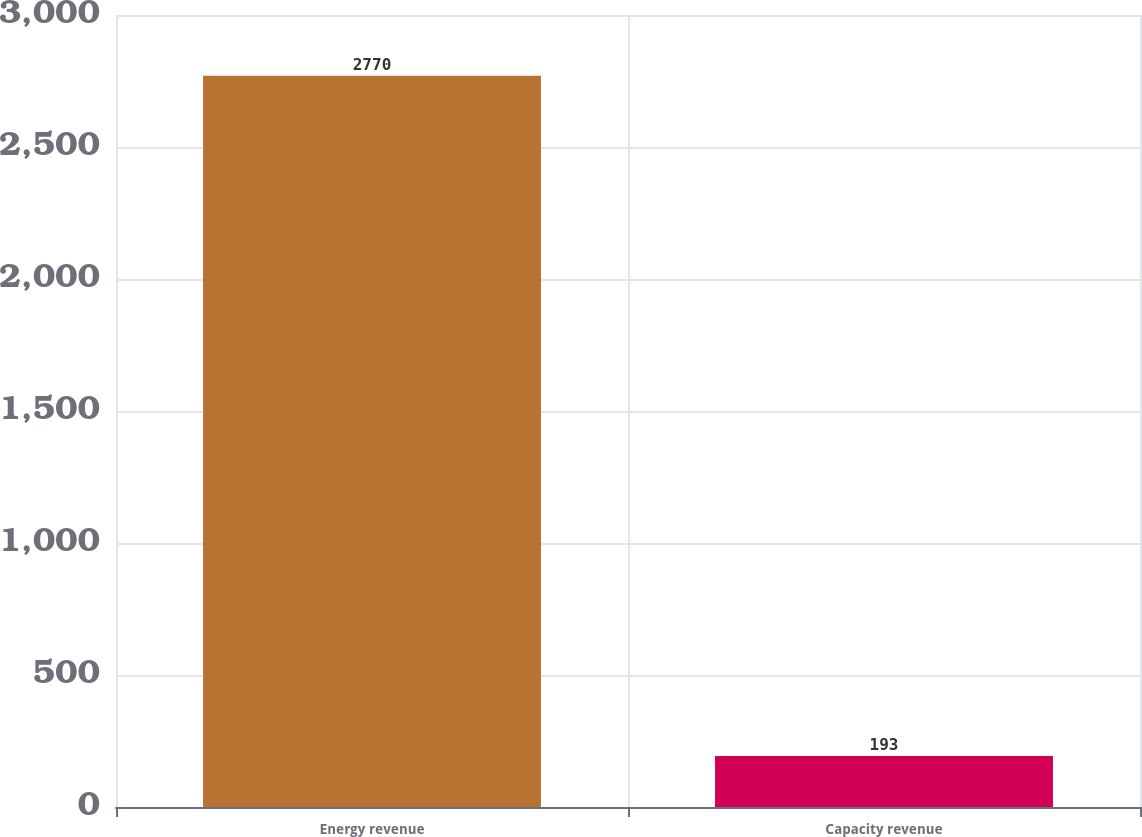<chart> <loc_0><loc_0><loc_500><loc_500><bar_chart><fcel>Energy revenue<fcel>Capacity revenue<nl><fcel>2770<fcel>193<nl></chart> 